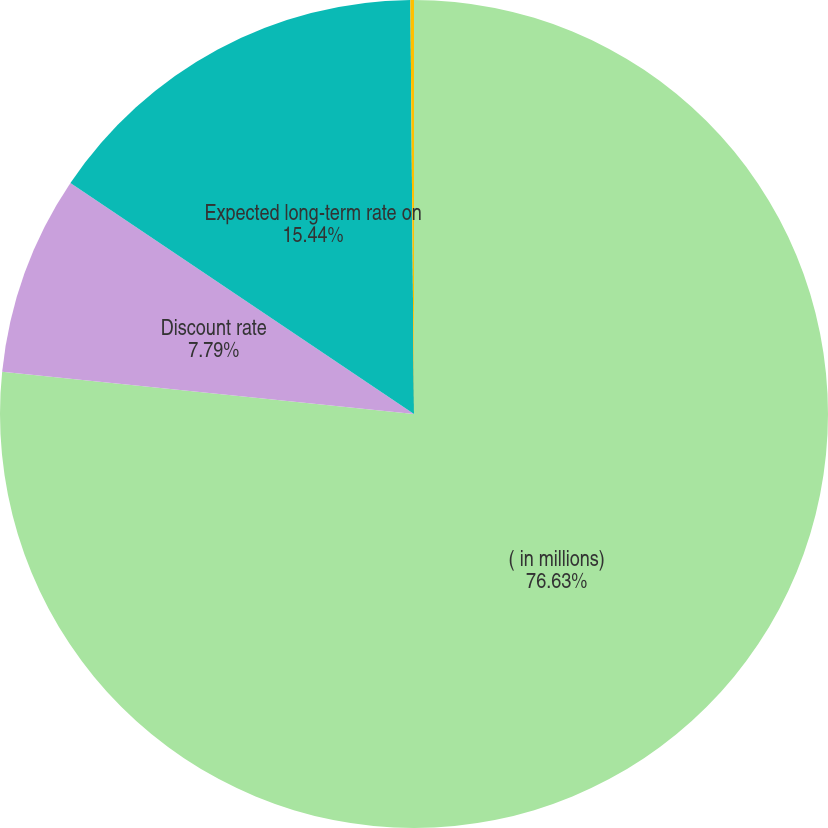Convert chart to OTSL. <chart><loc_0><loc_0><loc_500><loc_500><pie_chart><fcel>( in millions)<fcel>Discount rate<fcel>Expected long-term rate on<fcel>Rate of compensation increase<nl><fcel>76.63%<fcel>7.79%<fcel>15.44%<fcel>0.14%<nl></chart> 